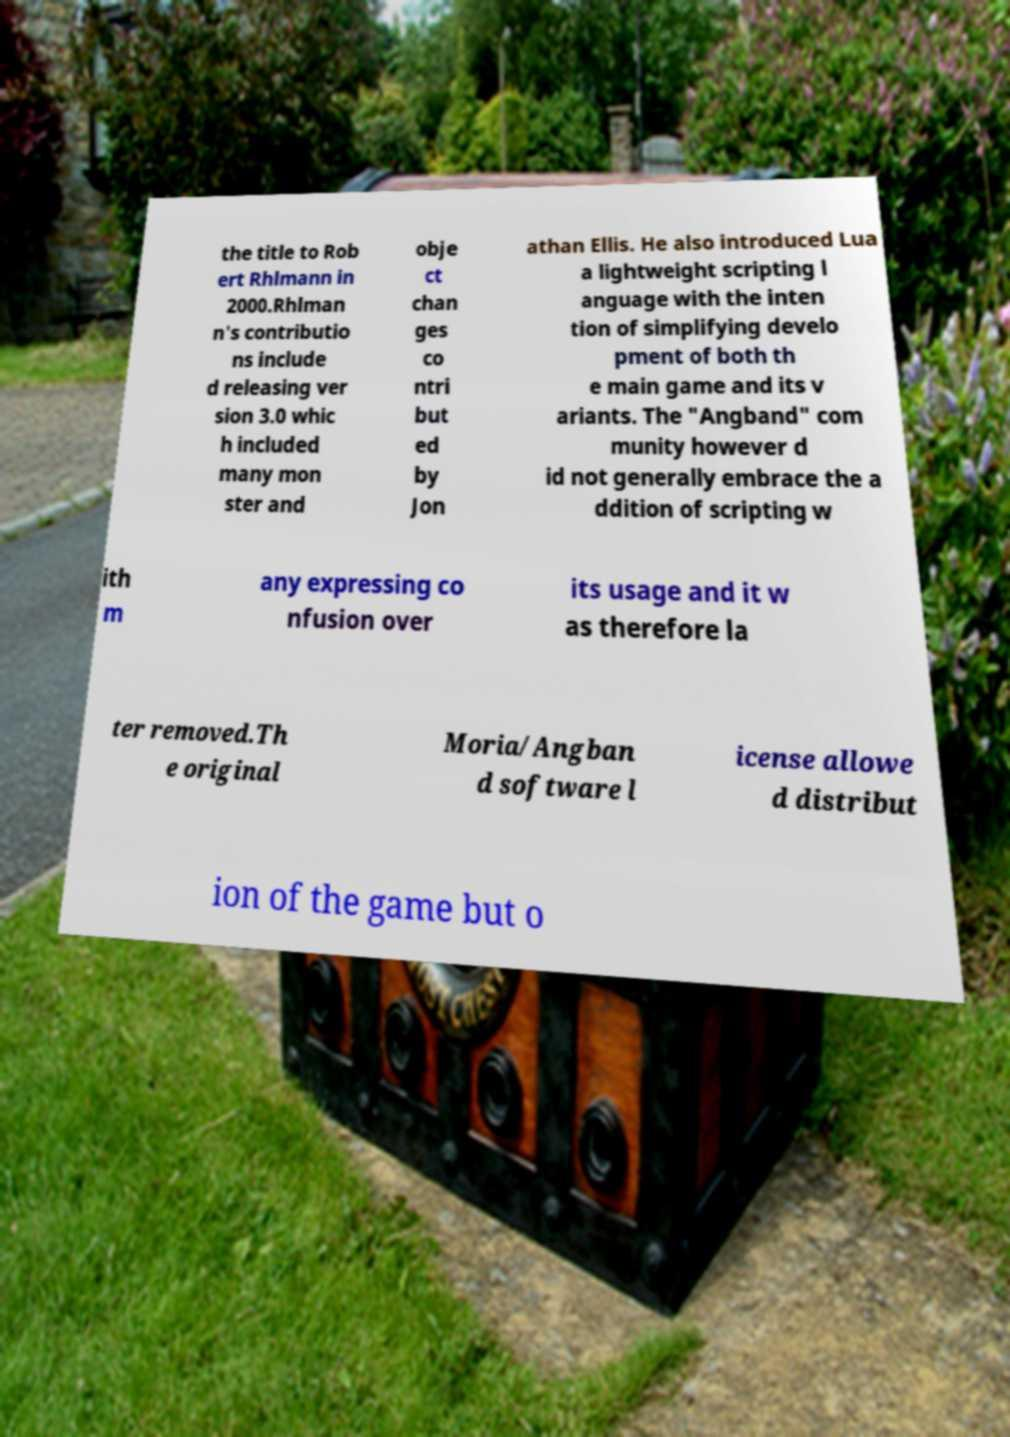Could you extract and type out the text from this image? the title to Rob ert Rhlmann in 2000.Rhlman n's contributio ns include d releasing ver sion 3.0 whic h included many mon ster and obje ct chan ges co ntri but ed by Jon athan Ellis. He also introduced Lua a lightweight scripting l anguage with the inten tion of simplifying develo pment of both th e main game and its v ariants. The "Angband" com munity however d id not generally embrace the a ddition of scripting w ith m any expressing co nfusion over its usage and it w as therefore la ter removed.Th e original Moria/Angban d software l icense allowe d distribut ion of the game but o 